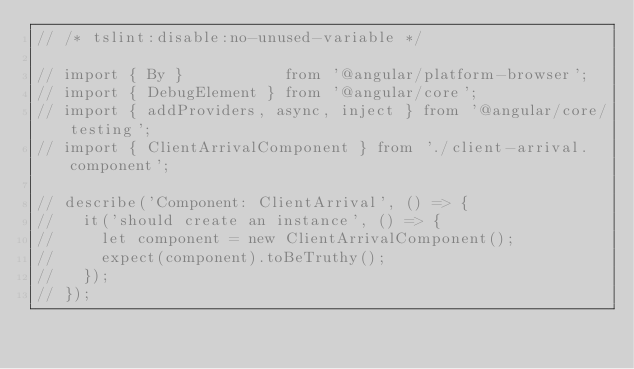Convert code to text. <code><loc_0><loc_0><loc_500><loc_500><_TypeScript_>// /* tslint:disable:no-unused-variable */

// import { By }           from '@angular/platform-browser';
// import { DebugElement } from '@angular/core';
// import { addProviders, async, inject } from '@angular/core/testing';
// import { ClientArrivalComponent } from './client-arrival.component';

// describe('Component: ClientArrival', () => {
//   it('should create an instance', () => {
//     let component = new ClientArrivalComponent();
//     expect(component).toBeTruthy();
//   });
// });
</code> 